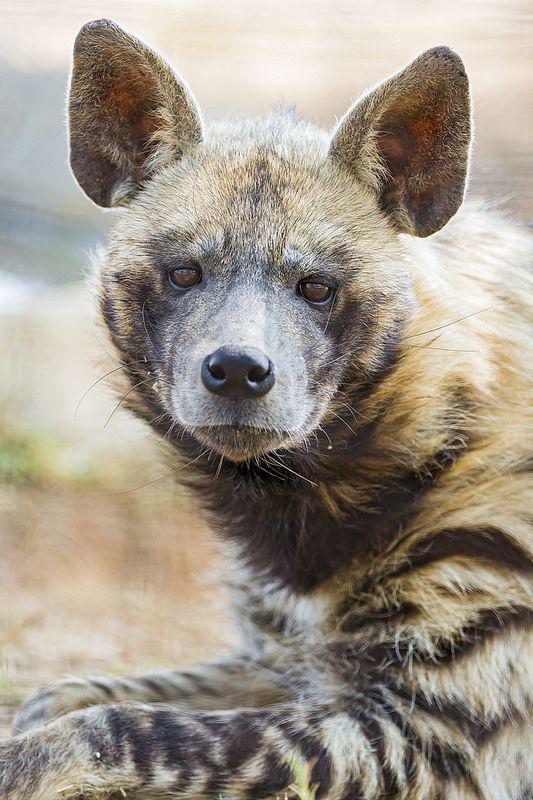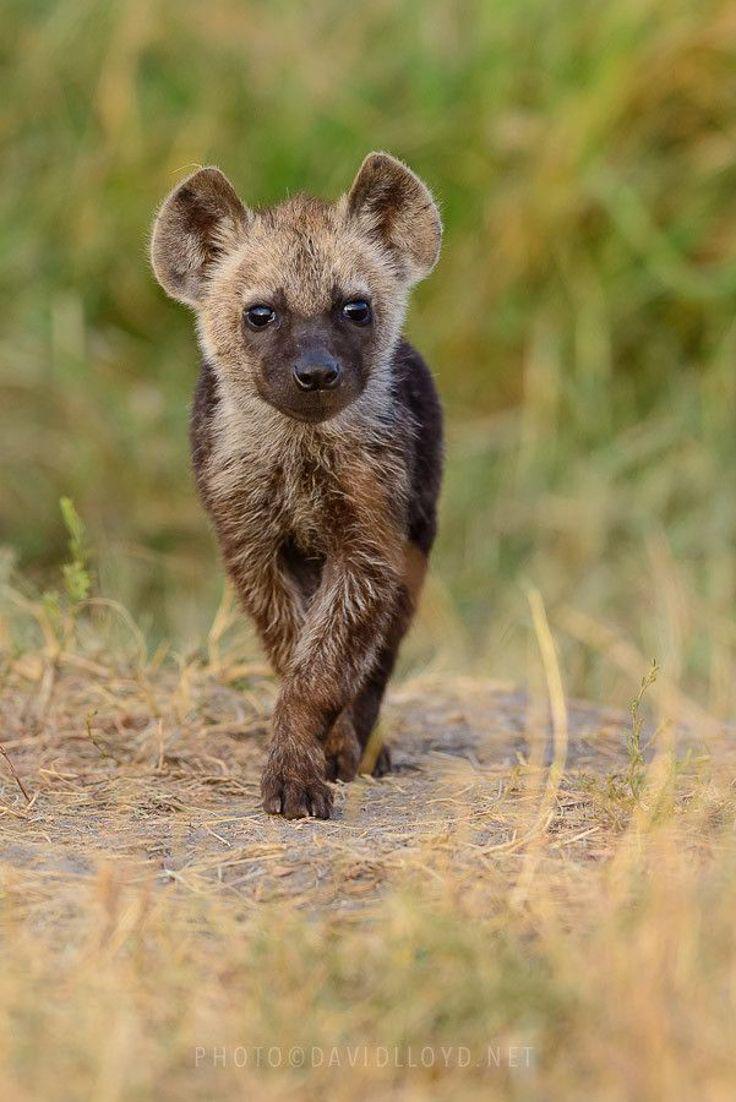The first image is the image on the left, the second image is the image on the right. Assess this claim about the two images: "There is an animal with its mouth open in one of the images.". Correct or not? Answer yes or no. No. 